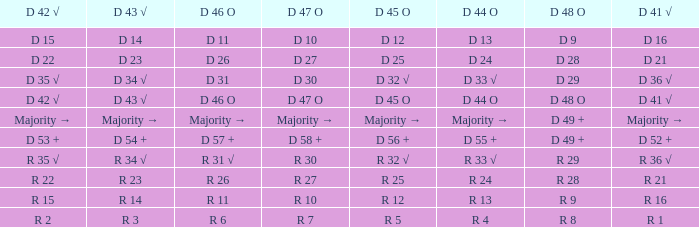Name the D 41 √ with D 44 O of r 13 R 16. 